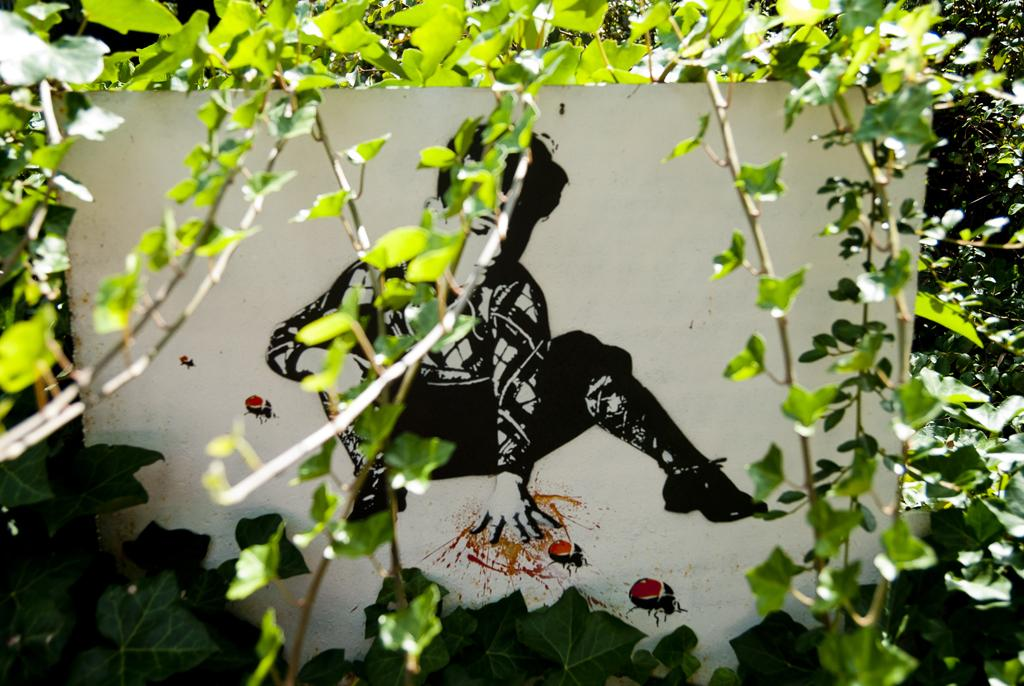What is featured on the poster in the image? The poster contains a picture of a boy. What else can be seen on the poster besides the boy's picture? There are no other elements mentioned on the poster. What type of plant is depicted in the image? There are stems with leaves in the image. What is the title of the book the boy is reading in the image? There is no book or title mentioned in the image; the poster only contains a picture of a boy. 